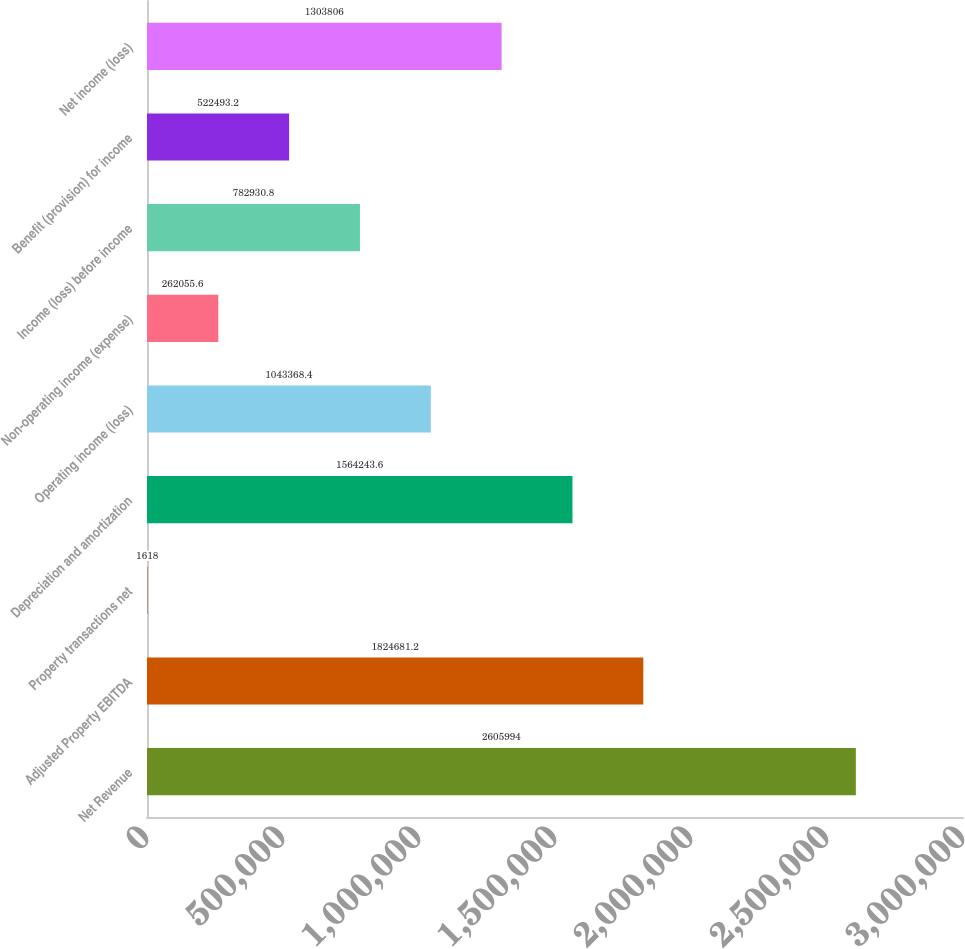Convert chart. <chart><loc_0><loc_0><loc_500><loc_500><bar_chart><fcel>Net Revenue<fcel>Adjusted Property EBITDA<fcel>Property transactions net<fcel>Depreciation and amortization<fcel>Operating income (loss)<fcel>Non-operating income (expense)<fcel>Income (loss) before income<fcel>Benefit (provision) for income<fcel>Net income (loss)<nl><fcel>2.60599e+06<fcel>1.82468e+06<fcel>1618<fcel>1.56424e+06<fcel>1.04337e+06<fcel>262056<fcel>782931<fcel>522493<fcel>1.30381e+06<nl></chart> 